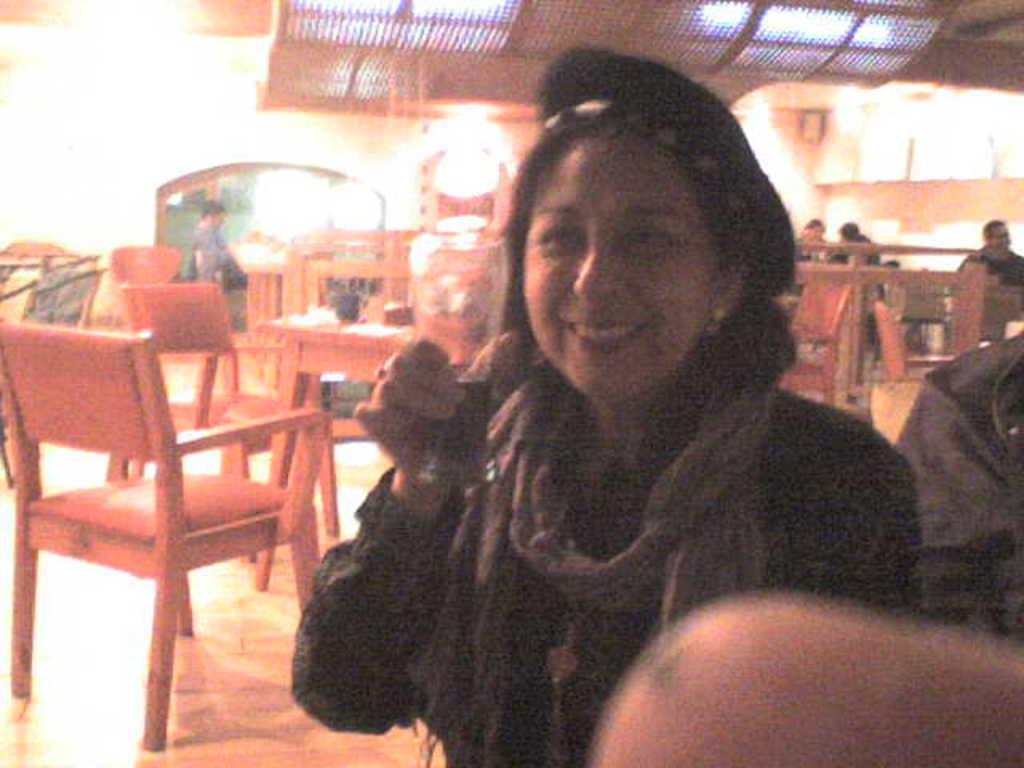Please provide a concise description of this image. In the image we can see there is a woman who is standing and holding glass in her hand and at the back there are lot of people who are sitting. 